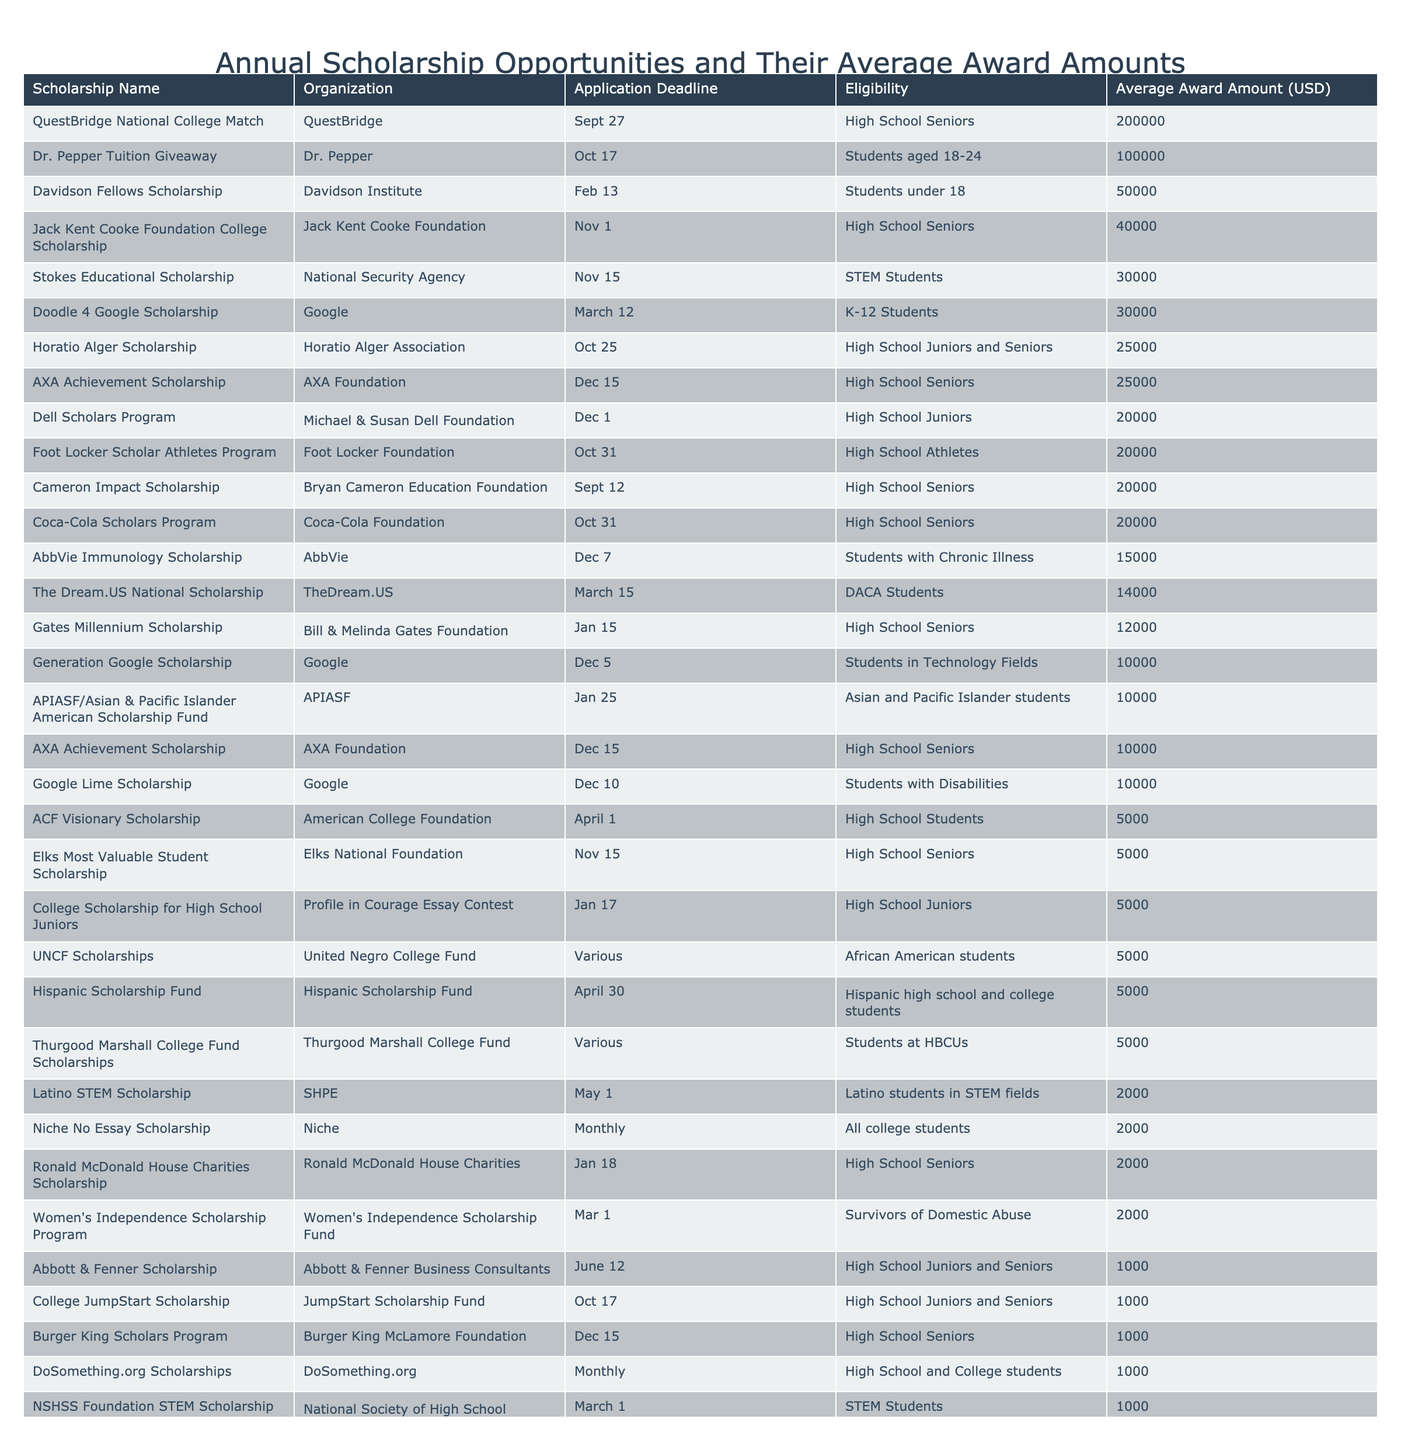What is the average award amount for the Gates Millennium Scholarship? The table shows that the average award amount for the Gates Millennium Scholarship is 12000 USD.
Answer: 12000 USD How many scholarships have an average award amount of 20000 USD? There are three scholarships listed in the table with an average award amount of 20000 USD: Coca-Cola Scholars Program, Dell Scholars Program, and Foot Locker Scholar Athletes Program.
Answer: 3 What is the highest average award amount for the scholarships listed? The table indicates that the highest average award amount is for the QuestBridge National College Match at 200000 USD.
Answer: 200000 USD Is the Davidson Fellows Scholarship available only for high school students? The Davidson Fellows Scholarship is available for students under 18, which may include high school students but is not limited to them.
Answer: No Calculate the total average award amount for the scholarships available to high school seniors. The total average award amounts for high school seniors include the following amounts: 12000 + 20000 + 5000 + 10000 + 40000 + 2000 + 25000 + 20000 = 115000 USD, where we sum the average awards specifically for scholarships listed as available to high school seniors.
Answer: 115000 USD Which scholarship has the earliest application deadline? Reviewing the application deadlines, the Gates Millennium Scholarship has the earliest application deadline on January 15.
Answer: Gates Millennium Scholarship Are there any scholarships specifically for students with disabilities? Yes, the Google Lime Scholarship is specifically for students with disabilities, as noted in the eligibility column of the table.
Answer: Yes Calculate the median average award amount from all the scholarship awards listed. First, we need to line up the average award amounts: 1000, 1000, 1500, 2000, 2000, 5000, 5000, 10000, 10000, 12000, 14000, 20000, 20000, 20000, 25000, 25000, 30000, 30000, 40000, 50000, 200000. After sorting these values, since there are 25 entries, the median value is the average of the 12th and 13th amounts, which are 20000 and 20000, giving us a median of 20000.
Answer: 20000 USD 